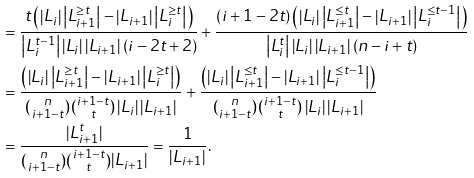<formula> <loc_0><loc_0><loc_500><loc_500>& = \frac { t \left ( \left | L _ { i } \right | \left | L _ { i + 1 } ^ { \geq t } \right | - \left | L _ { i + 1 } \right | \left | L _ { i } ^ { \geq t } \right | \right ) } { \left | L _ { i } ^ { t - 1 } \right | \left | L _ { i } \right | \left | L _ { i + 1 } \right | ( i - 2 t + 2 ) } + \frac { ( i + 1 - 2 t ) \left ( \left | L _ { i } \right | \left | L _ { i + 1 } ^ { \leq t } \right | - \left | L _ { i + 1 } \right | \left | L _ { i } ^ { \leq t - 1 } \right | \right ) } { \left | L _ { i } ^ { t } \right | \left | L _ { i } \right | \left | L _ { i + 1 } \right | ( n - i + t ) } \\ & = \frac { \left ( \left | L _ { i } \right | \left | L _ { i + 1 } ^ { \geq t } \right | - \left | L _ { i + 1 } \right | \left | L _ { i } ^ { \geq t } \right | \right ) } { \binom { n } { i + 1 - t } \binom { i + 1 - t } { t } \left | L _ { i } \right | \left | L _ { i + 1 } \right | } + \frac { \left ( \left | L _ { i } \right | \left | L _ { i + 1 } ^ { \leq t } \right | - \left | L _ { i + 1 } \right | \left | L _ { i } ^ { \leq t - 1 } \right | \right ) } { \binom { n } { i + 1 - t } \binom { i + 1 - t } { t } \left | L _ { i } \right | \left | L _ { i + 1 } \right | } \\ & = \frac { | L _ { i + 1 } ^ { t } | } { \binom { n } { i + 1 - t } \binom { i + 1 - t } { t } | L _ { i + 1 } | } = \frac { 1 } { \left | L _ { i + 1 } \right | } .</formula> 